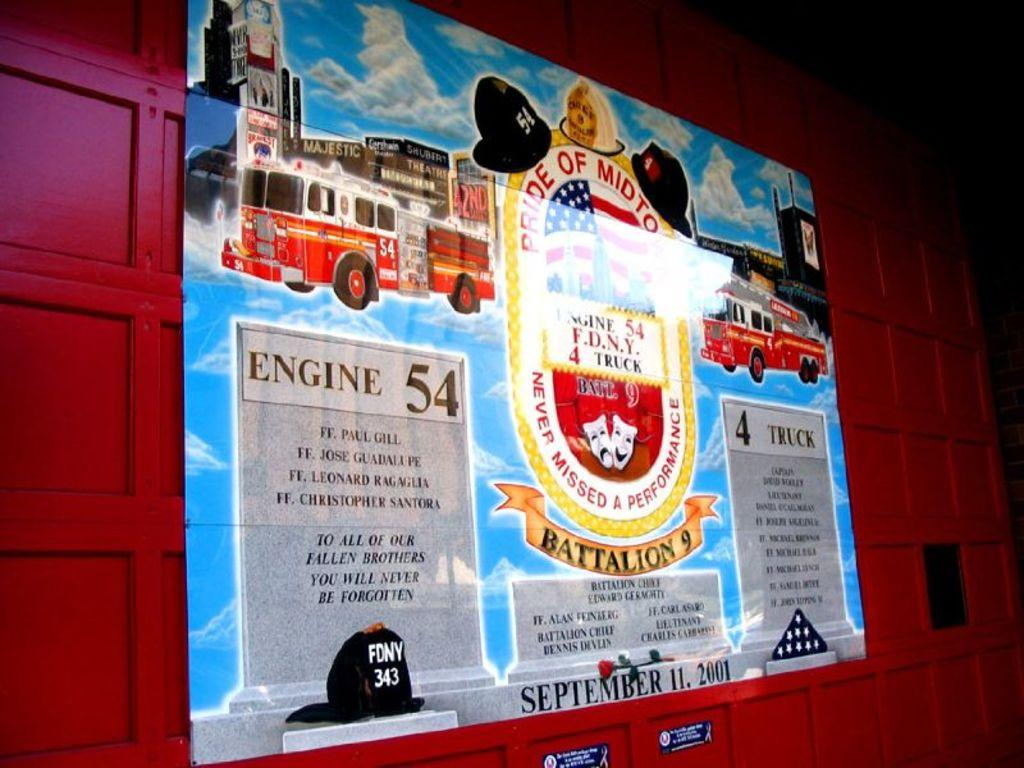<image>
Create a compact narrative representing the image presented. an infographic of engine 54 with several illustrations of fire trucks. 